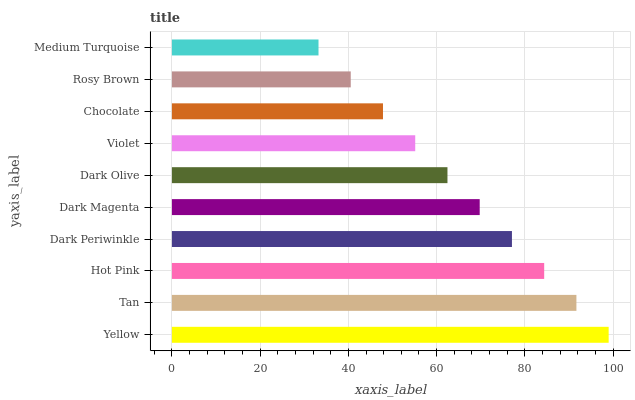Is Medium Turquoise the minimum?
Answer yes or no. Yes. Is Yellow the maximum?
Answer yes or no. Yes. Is Tan the minimum?
Answer yes or no. No. Is Tan the maximum?
Answer yes or no. No. Is Yellow greater than Tan?
Answer yes or no. Yes. Is Tan less than Yellow?
Answer yes or no. Yes. Is Tan greater than Yellow?
Answer yes or no. No. Is Yellow less than Tan?
Answer yes or no. No. Is Dark Magenta the high median?
Answer yes or no. Yes. Is Dark Olive the low median?
Answer yes or no. Yes. Is Yellow the high median?
Answer yes or no. No. Is Medium Turquoise the low median?
Answer yes or no. No. 